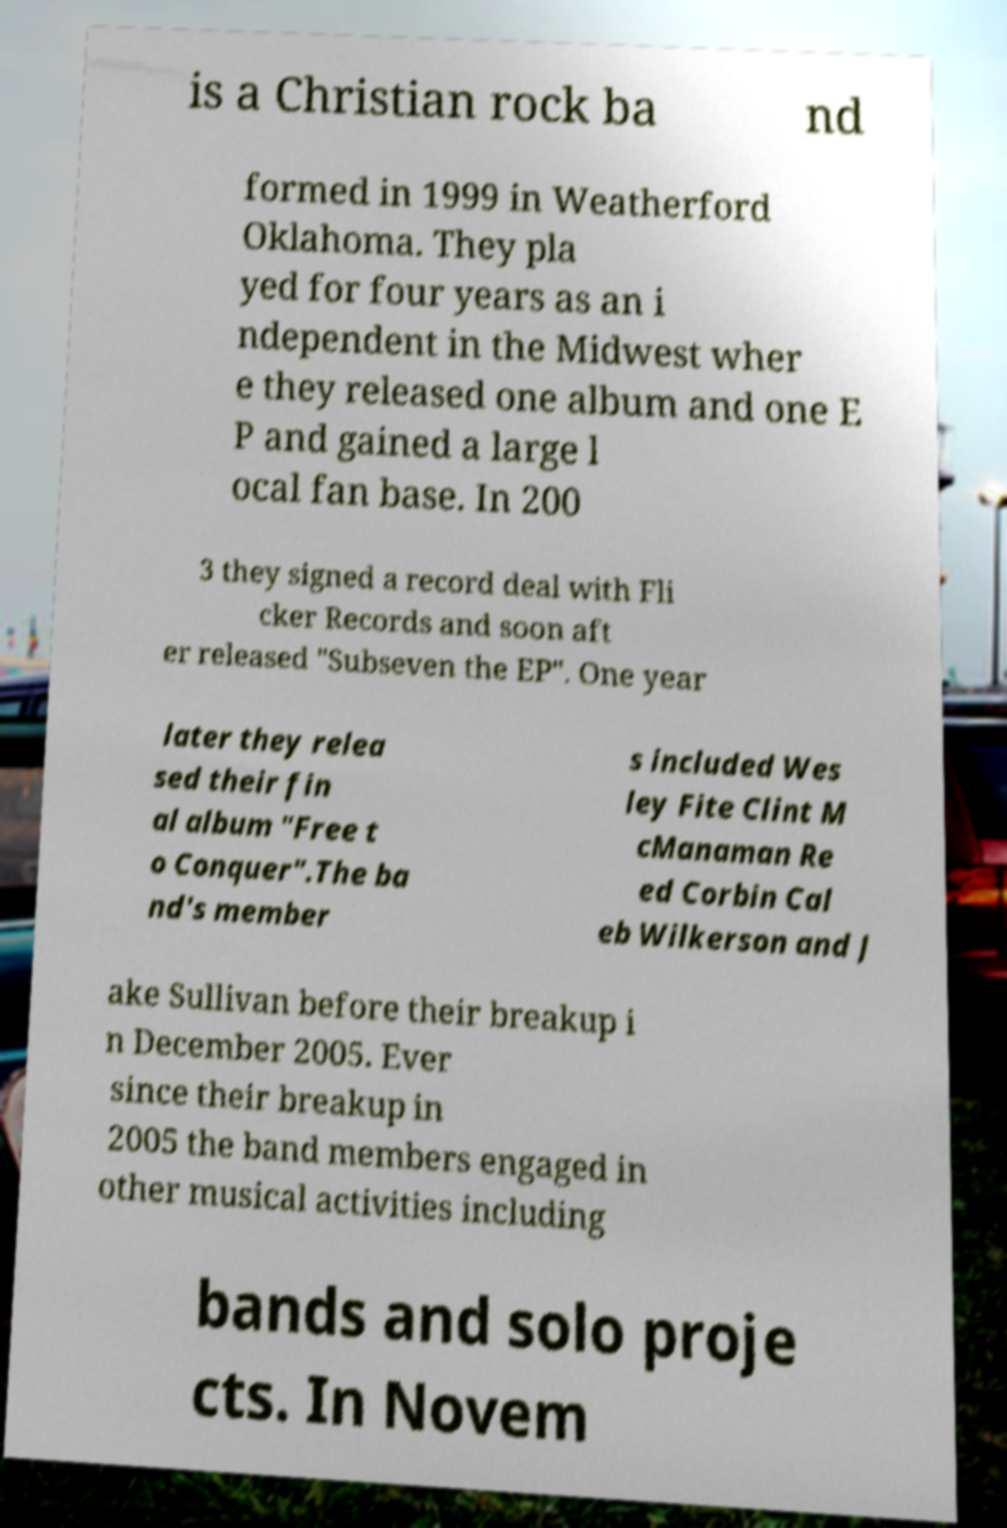Could you assist in decoding the text presented in this image and type it out clearly? is a Christian rock ba nd formed in 1999 in Weatherford Oklahoma. They pla yed for four years as an i ndependent in the Midwest wher e they released one album and one E P and gained a large l ocal fan base. In 200 3 they signed a record deal with Fli cker Records and soon aft er released "Subseven the EP". One year later they relea sed their fin al album "Free t o Conquer".The ba nd's member s included Wes ley Fite Clint M cManaman Re ed Corbin Cal eb Wilkerson and J ake Sullivan before their breakup i n December 2005. Ever since their breakup in 2005 the band members engaged in other musical activities including bands and solo proje cts. In Novem 